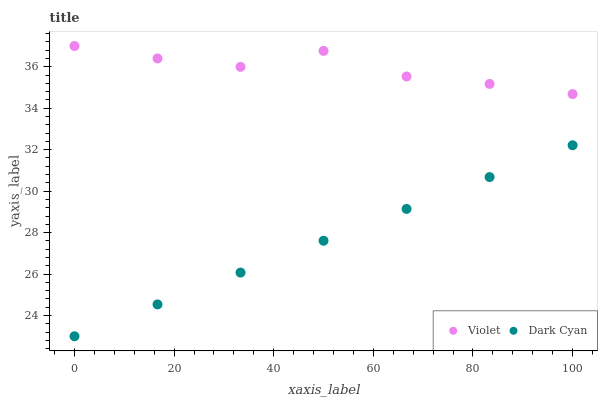Does Dark Cyan have the minimum area under the curve?
Answer yes or no. Yes. Does Violet have the maximum area under the curve?
Answer yes or no. Yes. Does Violet have the minimum area under the curve?
Answer yes or no. No. Is Dark Cyan the smoothest?
Answer yes or no. Yes. Is Violet the roughest?
Answer yes or no. Yes. Is Violet the smoothest?
Answer yes or no. No. Does Dark Cyan have the lowest value?
Answer yes or no. Yes. Does Violet have the lowest value?
Answer yes or no. No. Does Violet have the highest value?
Answer yes or no. Yes. Is Dark Cyan less than Violet?
Answer yes or no. Yes. Is Violet greater than Dark Cyan?
Answer yes or no. Yes. Does Dark Cyan intersect Violet?
Answer yes or no. No. 